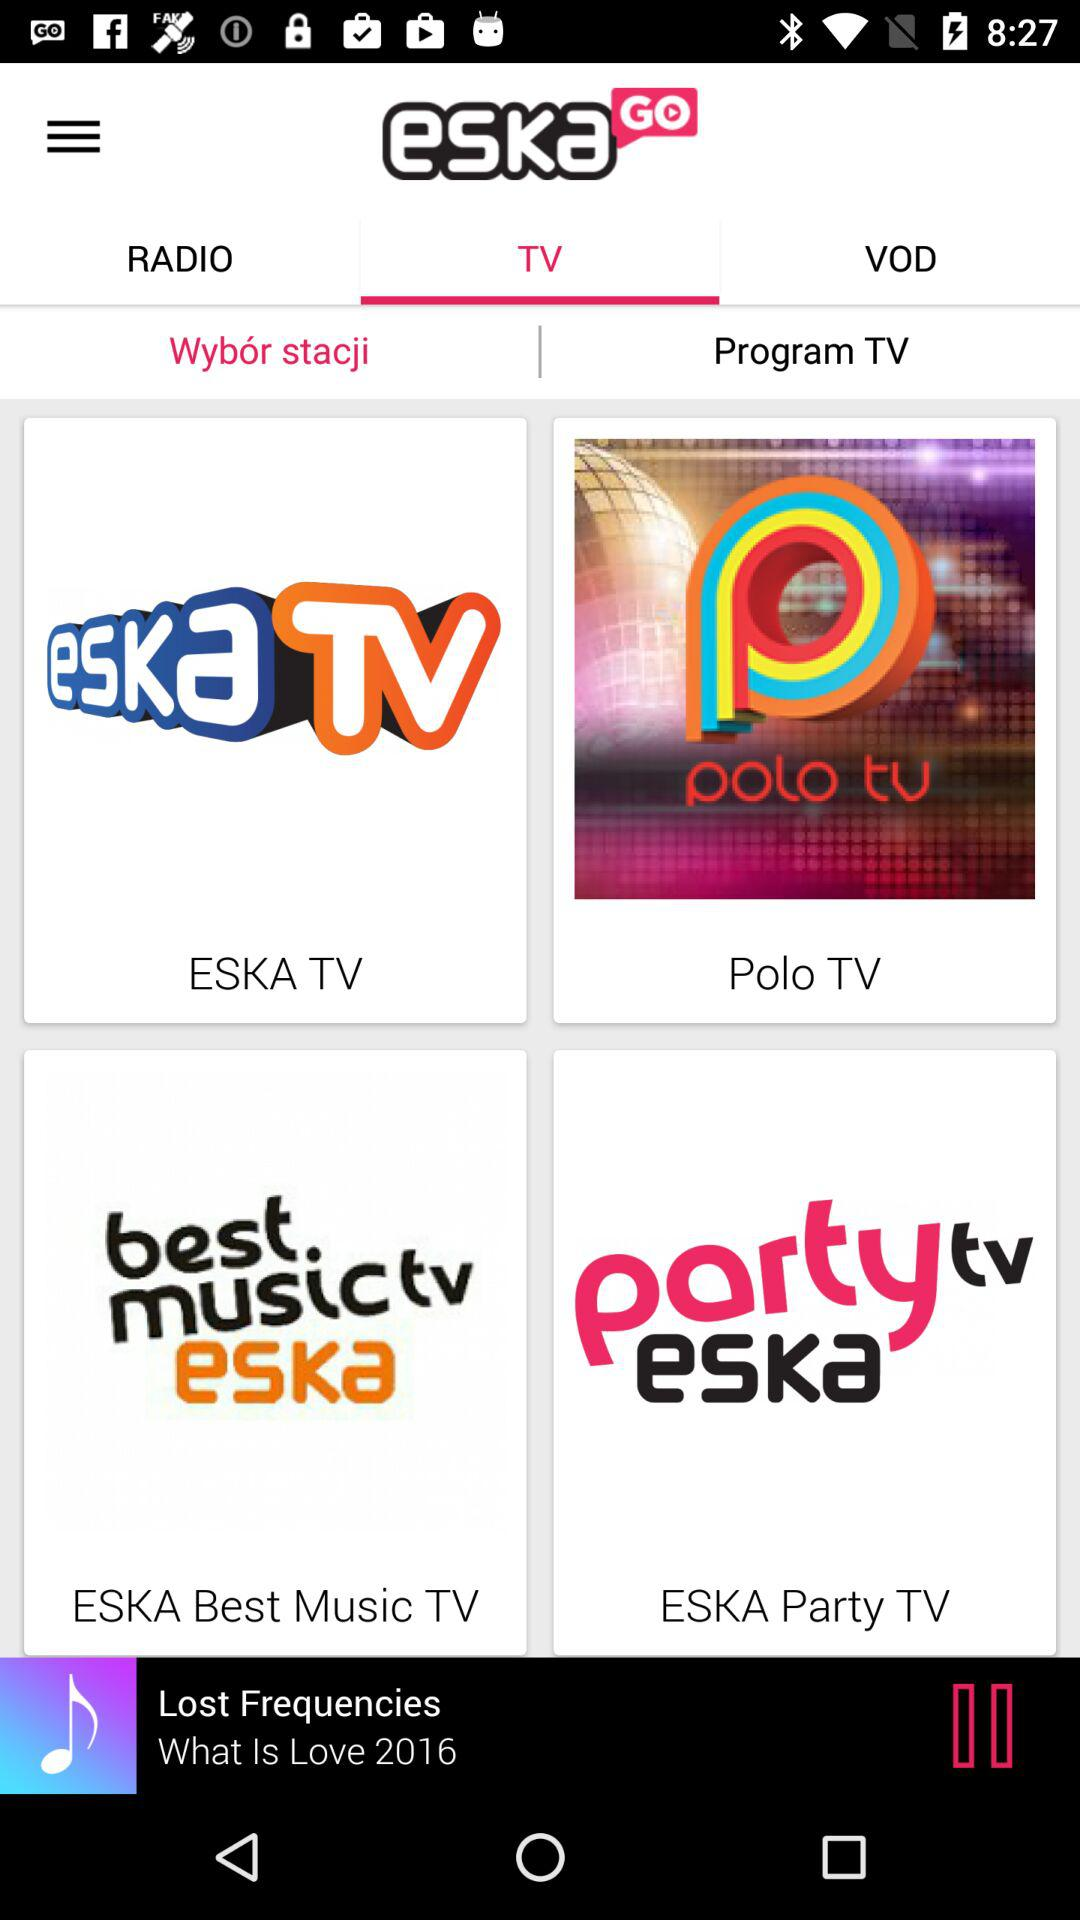Which different television channels are shown? The different television channels are "ESKA TV", "Polo TV", "ESKA Best Music TV" and "ESKA Party TV". 